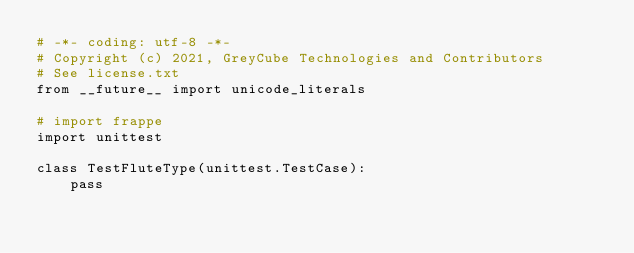Convert code to text. <code><loc_0><loc_0><loc_500><loc_500><_Python_># -*- coding: utf-8 -*-
# Copyright (c) 2021, GreyCube Technologies and Contributors
# See license.txt
from __future__ import unicode_literals

# import frappe
import unittest

class TestFluteType(unittest.TestCase):
	pass
</code> 